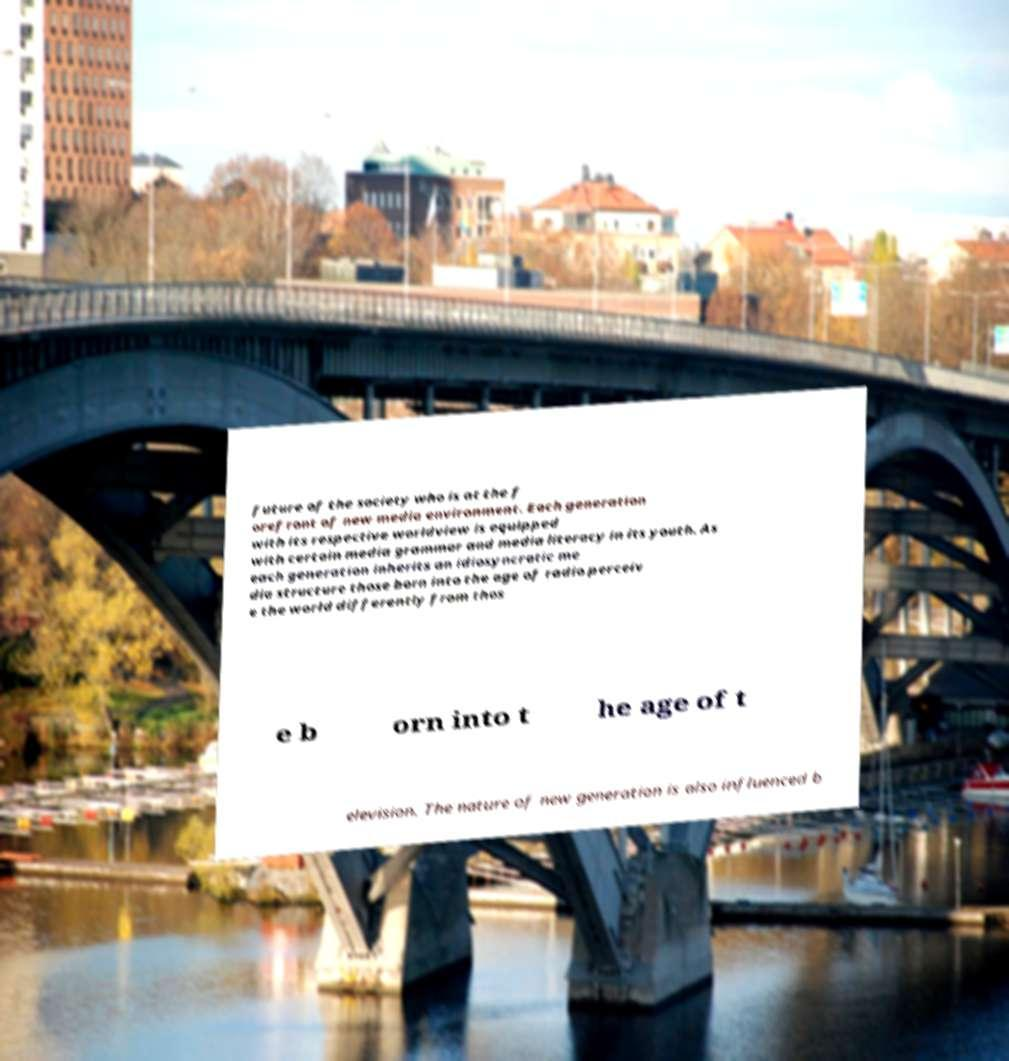I need the written content from this picture converted into text. Can you do that? future of the society who is at the f orefront of new media environment. Each generation with its respective worldview is equipped with certain media grammar and media literacy in its youth. As each generation inherits an idiosyncratic me dia structure those born into the age of radio perceiv e the world differently from thos e b orn into t he age of t elevision. The nature of new generation is also influenced b 